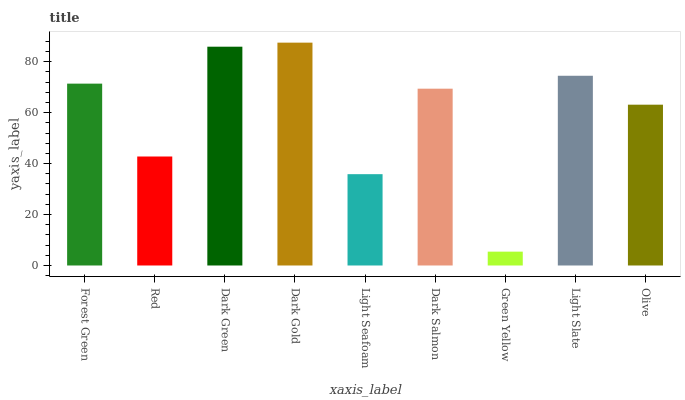Is Green Yellow the minimum?
Answer yes or no. Yes. Is Dark Gold the maximum?
Answer yes or no. Yes. Is Red the minimum?
Answer yes or no. No. Is Red the maximum?
Answer yes or no. No. Is Forest Green greater than Red?
Answer yes or no. Yes. Is Red less than Forest Green?
Answer yes or no. Yes. Is Red greater than Forest Green?
Answer yes or no. No. Is Forest Green less than Red?
Answer yes or no. No. Is Dark Salmon the high median?
Answer yes or no. Yes. Is Dark Salmon the low median?
Answer yes or no. Yes. Is Green Yellow the high median?
Answer yes or no. No. Is Green Yellow the low median?
Answer yes or no. No. 